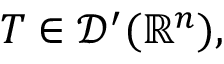Convert formula to latex. <formula><loc_0><loc_0><loc_500><loc_500>T \in { \mathcal { D } } ^ { \prime } ( \mathbb { R } ^ { n } ) ,</formula> 